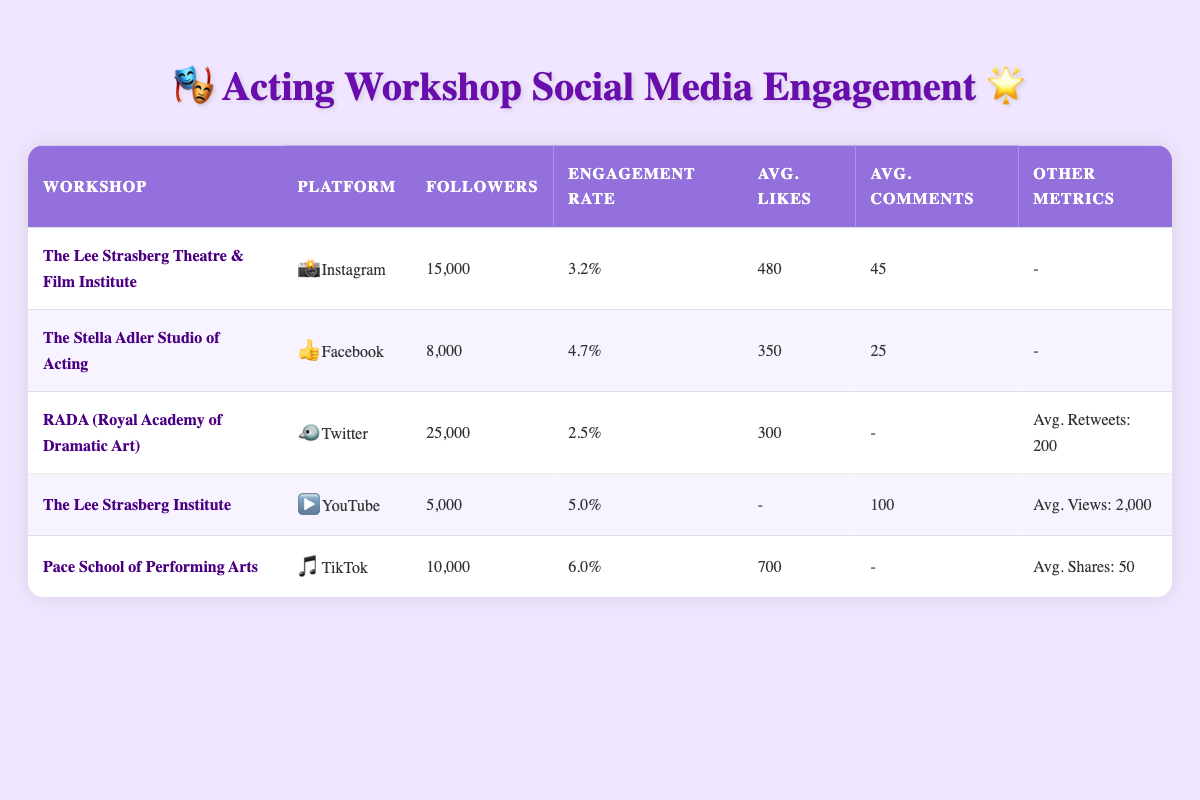What is the engagement rate of The Lee Strasberg Theatre & Film Institute? The table shows that the engagement rate for The Lee Strasberg Theatre & Film Institute is listed under the relevant column, which states it is 3.2%.
Answer: 3.2% Which workshop has the highest number of followers? By examining the 'Followers' column in the table, RADA (Royal Academy of Dramatic Art) has 25,000 followers, which is the highest compared to other workshops.
Answer: RADA (Royal Academy of Dramatic Art) What is the average engagement rate of all the workshops listed? To find the average engagement rate, add the engagement rates of all workshops: 3.2 + 4.7 + 2.5 + 5.0 + 6.0 = 21.4. There are 5 workshops, so the average is 21.4 / 5 = 4.28%.
Answer: 4.28% Does The Stella Adler Studio of Acting have more engagement than The Lee Strasberg Theatre & Film Institute? The engagement rate for The Stella Adler Studio of Acting is 4.7%, while The Lee Strasberg Theatre & Film Institute has an engagement rate of 3.2%. Since 4.7% is greater than 3.2%, the statement is true.
Answer: Yes If you combine the average likes per post from Instagram and Facebook, what is the total? The average likes per post for Instagram (The Lee Strasberg Theatre & Film Institute) is 480 and for Facebook (The Stella Adler Studio of Acting) is 350. Adding these together gives: 480 + 350 = 830.
Answer: 830 Which workshop has the lowest engagement rate and what is it? By reviewing the engagement rates, RADA (Royal Academy of Dramatic Art) has the lowest engagement rate at 2.5%.
Answer: RADA (Royal Academy of Dramatic Art), 2.5% How many average likes does Pace School of Performing Arts receive per video on TikTok? The table shows that the average likes per video for Pace School of Performing Arts on TikTok is 700, which is specifically mentioned in the relevant column.
Answer: 700 Is there a workshop that has both a high engagement rate and a high number of followers? To analyze this, we look for a workshop with a high engagement rate (above 5%) and a significant number of followers (above 10,000). Pace School of Performing Arts has an engagement rate of 6.0% and 10,000 followers, qualifying it as having both high engagement and followers.
Answer: Yes, Pace School of Performing Arts What is the average number of comments per post for The Lee Strasberg Institute on YouTube? According to the table, the average number of comments per video for The Lee Strasberg Institute on YouTube is 100. This detail is found directly under the average comments column specific to that workshop.
Answer: 100 